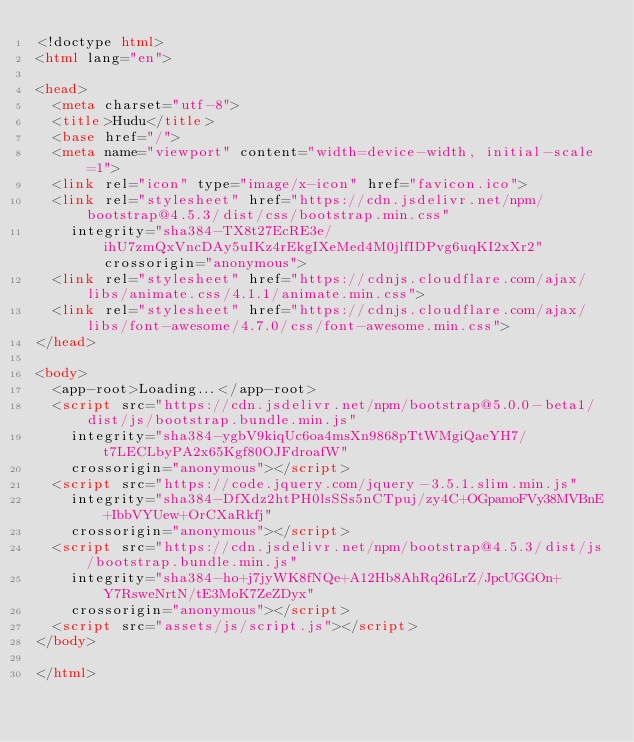<code> <loc_0><loc_0><loc_500><loc_500><_HTML_><!doctype html>
<html lang="en">

<head>
  <meta charset="utf-8">
  <title>Hudu</title>
  <base href="/">
  <meta name="viewport" content="width=device-width, initial-scale=1">
  <link rel="icon" type="image/x-icon" href="favicon.ico">
  <link rel="stylesheet" href="https://cdn.jsdelivr.net/npm/bootstrap@4.5.3/dist/css/bootstrap.min.css"
    integrity="sha384-TX8t27EcRE3e/ihU7zmQxVncDAy5uIKz4rEkgIXeMed4M0jlfIDPvg6uqKI2xXr2" crossorigin="anonymous">
  <link rel="stylesheet" href="https://cdnjs.cloudflare.com/ajax/libs/animate.css/4.1.1/animate.min.css">
  <link rel="stylesheet" href="https://cdnjs.cloudflare.com/ajax/libs/font-awesome/4.7.0/css/font-awesome.min.css">
</head>

<body>
  <app-root>Loading...</app-root>
  <script src="https://cdn.jsdelivr.net/npm/bootstrap@5.0.0-beta1/dist/js/bootstrap.bundle.min.js"
    integrity="sha384-ygbV9kiqUc6oa4msXn9868pTtWMgiQaeYH7/t7LECLbyPA2x65Kgf80OJFdroafW"
    crossorigin="anonymous"></script>
  <script src="https://code.jquery.com/jquery-3.5.1.slim.min.js"
    integrity="sha384-DfXdz2htPH0lsSSs5nCTpuj/zy4C+OGpamoFVy38MVBnE+IbbVYUew+OrCXaRkfj"
    crossorigin="anonymous"></script>
  <script src="https://cdn.jsdelivr.net/npm/bootstrap@4.5.3/dist/js/bootstrap.bundle.min.js"
    integrity="sha384-ho+j7jyWK8fNQe+A12Hb8AhRq26LrZ/JpcUGGOn+Y7RsweNrtN/tE3MoK7ZeZDyx"
    crossorigin="anonymous"></script>
  <script src="assets/js/script.js"></script>
</body>

</html></code> 